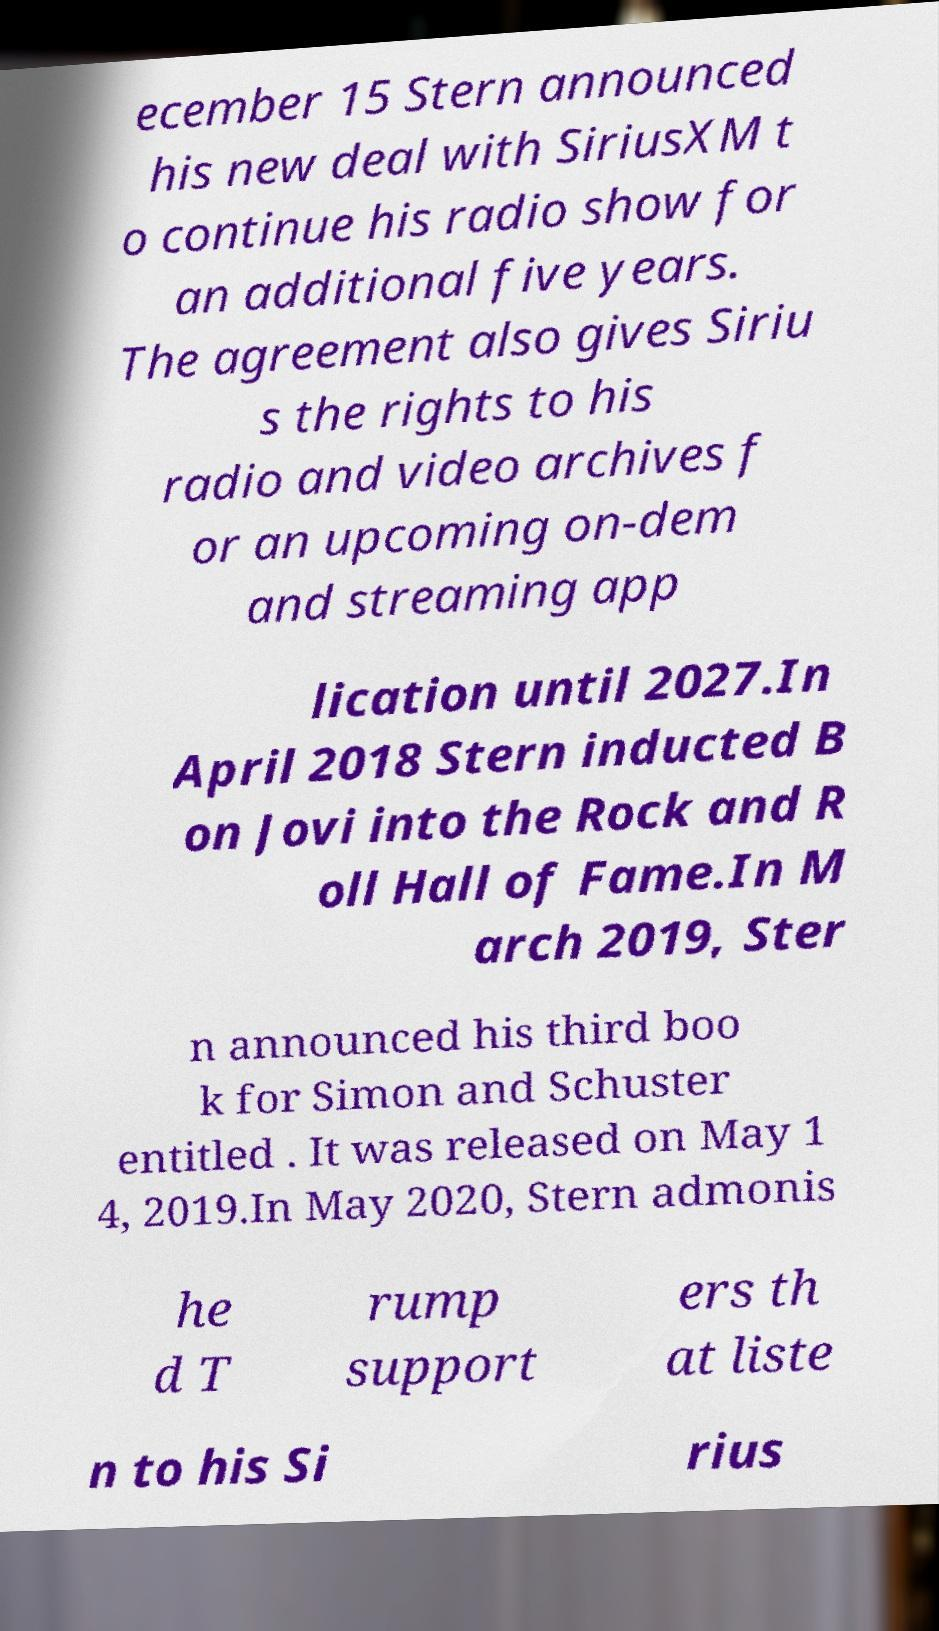Can you read and provide the text displayed in the image?This photo seems to have some interesting text. Can you extract and type it out for me? ecember 15 Stern announced his new deal with SiriusXM t o continue his radio show for an additional five years. The agreement also gives Siriu s the rights to his radio and video archives f or an upcoming on-dem and streaming app lication until 2027.In April 2018 Stern inducted B on Jovi into the Rock and R oll Hall of Fame.In M arch 2019, Ster n announced his third boo k for Simon and Schuster entitled . It was released on May 1 4, 2019.In May 2020, Stern admonis he d T rump support ers th at liste n to his Si rius 